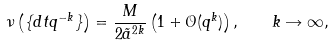Convert formula to latex. <formula><loc_0><loc_0><loc_500><loc_500>\nu \left ( \{ d t q ^ { - k } \} \right ) = \frac { M } { 2 \tilde { a } ^ { 2 k } } \left ( 1 + \mathcal { O } ( q ^ { k } ) \right ) , \quad k \rightarrow \infty ,</formula> 